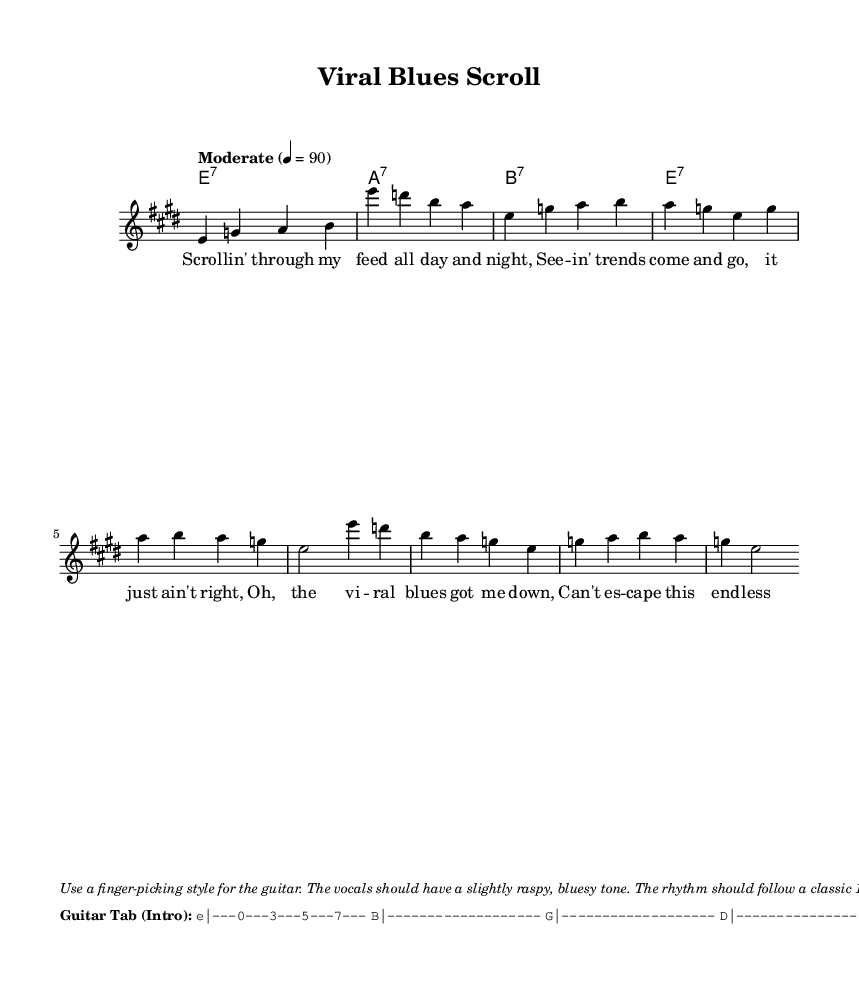What is the key signature of this music? The key signature is E major, which has four sharps (F#, C#, G#, D#). This can be identified at the beginning of the music staff.
Answer: E major What is the time signature of this music? The time signature is 4/4, which is indicated at the beginning of the sheet music. This means there are four beats in each measure.
Answer: 4/4 What is the tempo marking for this piece? The tempo marking is "Moderate" with a metronome marking of 90 beats per minute. This indication helps determine the speed of the performance.
Answer: Moderate 4 = 90 How many measures are in the verse section? The verse section consists of two measures, as visible from counting the notes laid out in the melody part.
Answer: 2 What playing style is suggested for the guitar? The suggested playing style is finger-picking, noted in the performance direction at the bottom of the sheet music.
Answer: Finger-picking What type of chord progression is used in the song? The chord progression follows a blues pattern, utilizing seventh chords (dominant 7ths), which is characteristic of the blues genre.
Answer: Seventh chords What thematic element is present in the lyrics? The lyrics focus on the experience of scrolling through internet trends, blending modern themes with the traditional storytelling of blues music.
Answer: Viral internet trends 